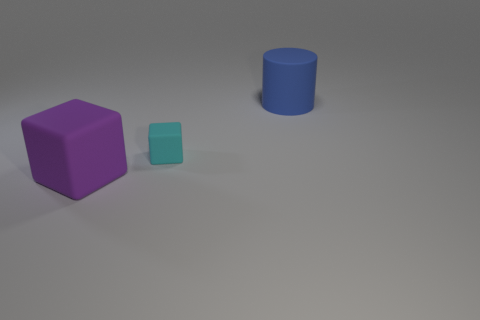How many objects are either matte things behind the large purple rubber object or things that are on the left side of the cyan cube?
Ensure brevity in your answer.  3. What number of other things are the same size as the cyan thing?
Keep it short and to the point. 0. What shape is the big object in front of the large object that is to the right of the cyan matte thing?
Ensure brevity in your answer.  Cube. The big rubber cylinder has what color?
Make the answer very short. Blue. Are there any large purple cubes?
Ensure brevity in your answer.  Yes. Are there any blue rubber cylinders behind the purple matte object?
Your answer should be very brief. Yes. What is the material of the tiny cyan object that is the same shape as the purple thing?
Your answer should be compact. Rubber. How many other objects are there of the same shape as the cyan matte object?
Give a very brief answer. 1. What number of cyan matte objects are in front of the large matte object that is in front of the matte cube that is to the right of the large purple rubber thing?
Provide a short and direct response. 0. What number of other things are the same shape as the purple thing?
Provide a short and direct response. 1. 